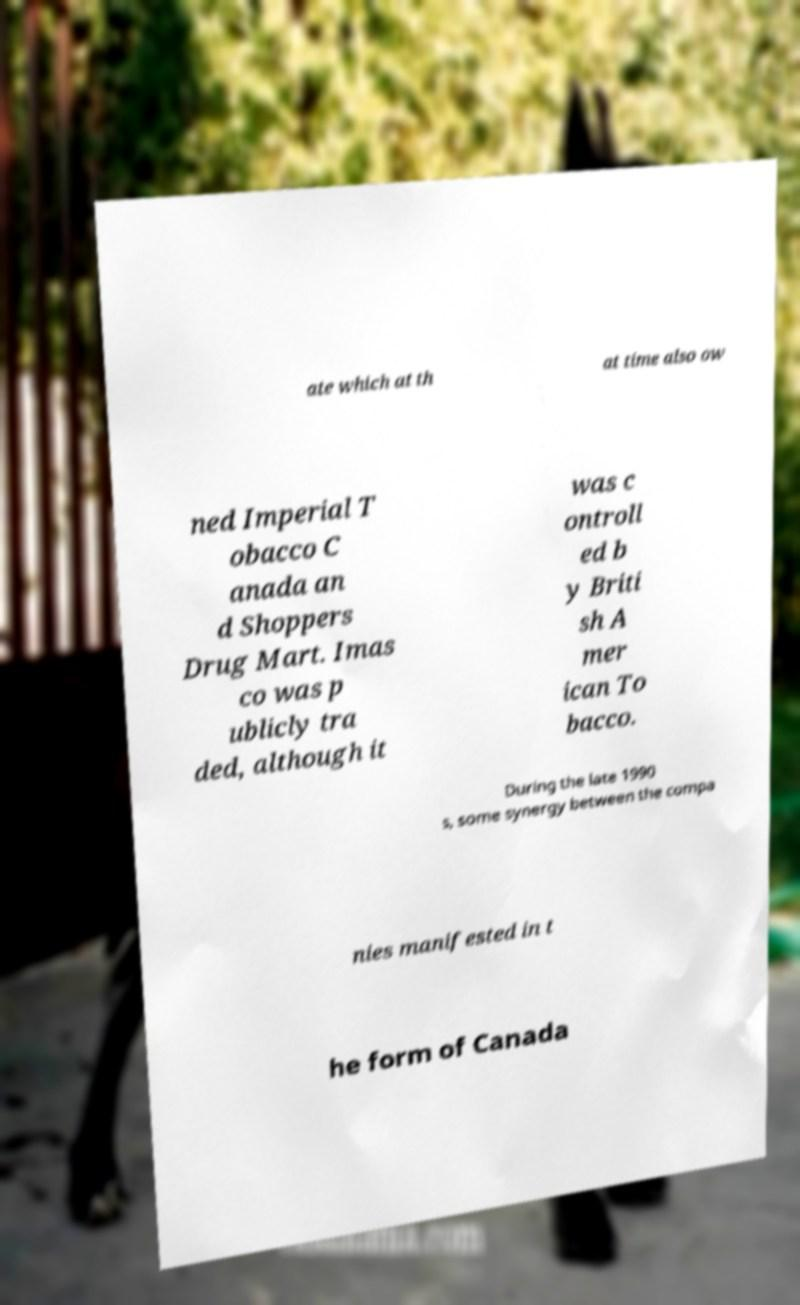For documentation purposes, I need the text within this image transcribed. Could you provide that? ate which at th at time also ow ned Imperial T obacco C anada an d Shoppers Drug Mart. Imas co was p ublicly tra ded, although it was c ontroll ed b y Briti sh A mer ican To bacco. During the late 1990 s, some synergy between the compa nies manifested in t he form of Canada 